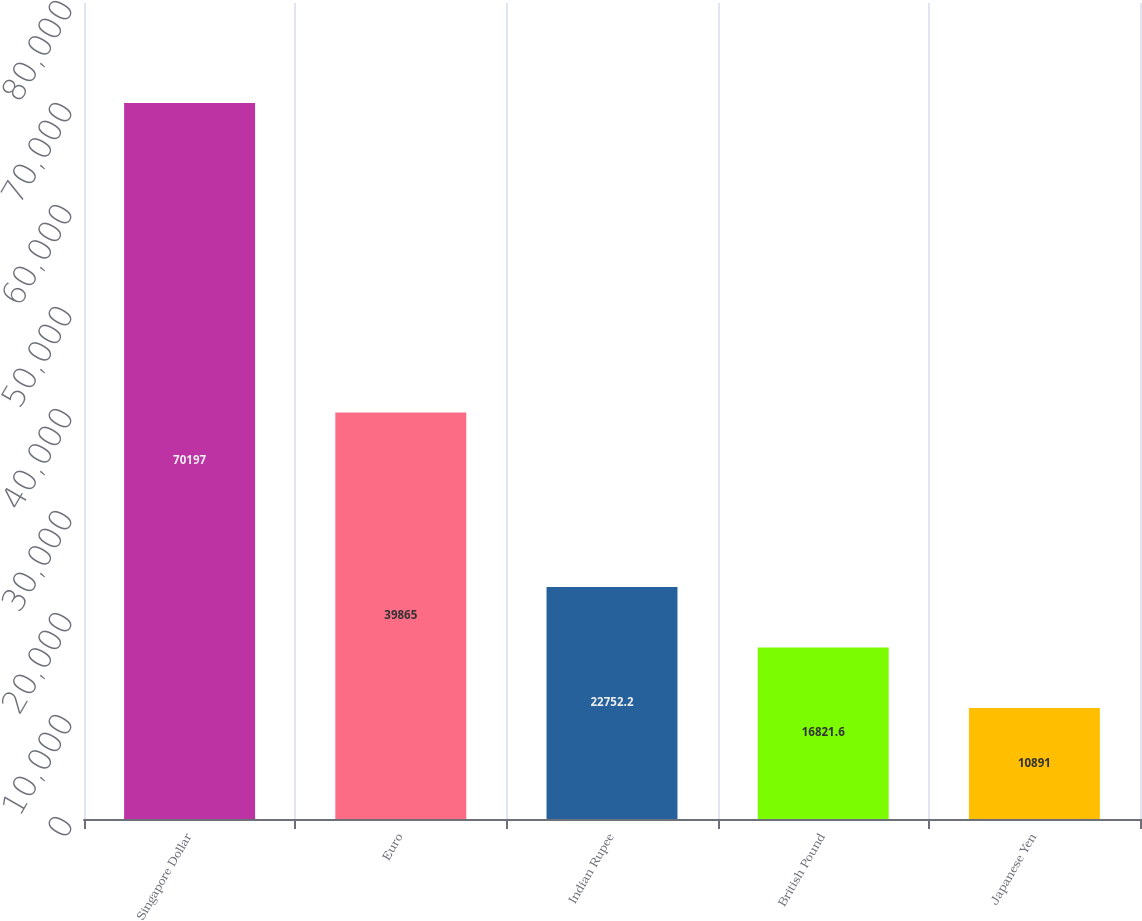<chart> <loc_0><loc_0><loc_500><loc_500><bar_chart><fcel>Singapore Dollar<fcel>Euro<fcel>Indian Rupee<fcel>British Pound<fcel>Japanese Yen<nl><fcel>70197<fcel>39865<fcel>22752.2<fcel>16821.6<fcel>10891<nl></chart> 